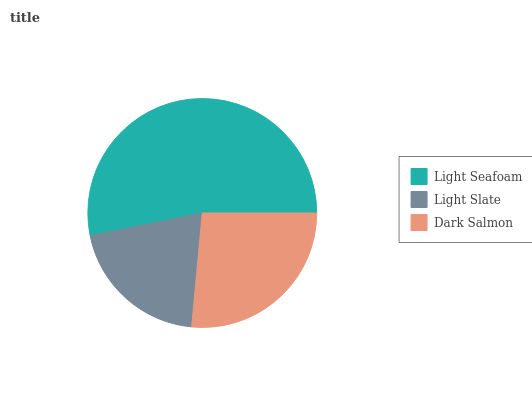Is Light Slate the minimum?
Answer yes or no. Yes. Is Light Seafoam the maximum?
Answer yes or no. Yes. Is Dark Salmon the minimum?
Answer yes or no. No. Is Dark Salmon the maximum?
Answer yes or no. No. Is Dark Salmon greater than Light Slate?
Answer yes or no. Yes. Is Light Slate less than Dark Salmon?
Answer yes or no. Yes. Is Light Slate greater than Dark Salmon?
Answer yes or no. No. Is Dark Salmon less than Light Slate?
Answer yes or no. No. Is Dark Salmon the high median?
Answer yes or no. Yes. Is Dark Salmon the low median?
Answer yes or no. Yes. Is Light Seafoam the high median?
Answer yes or no. No. Is Light Seafoam the low median?
Answer yes or no. No. 